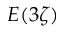<formula> <loc_0><loc_0><loc_500><loc_500>E ( 3 \zeta )</formula> 